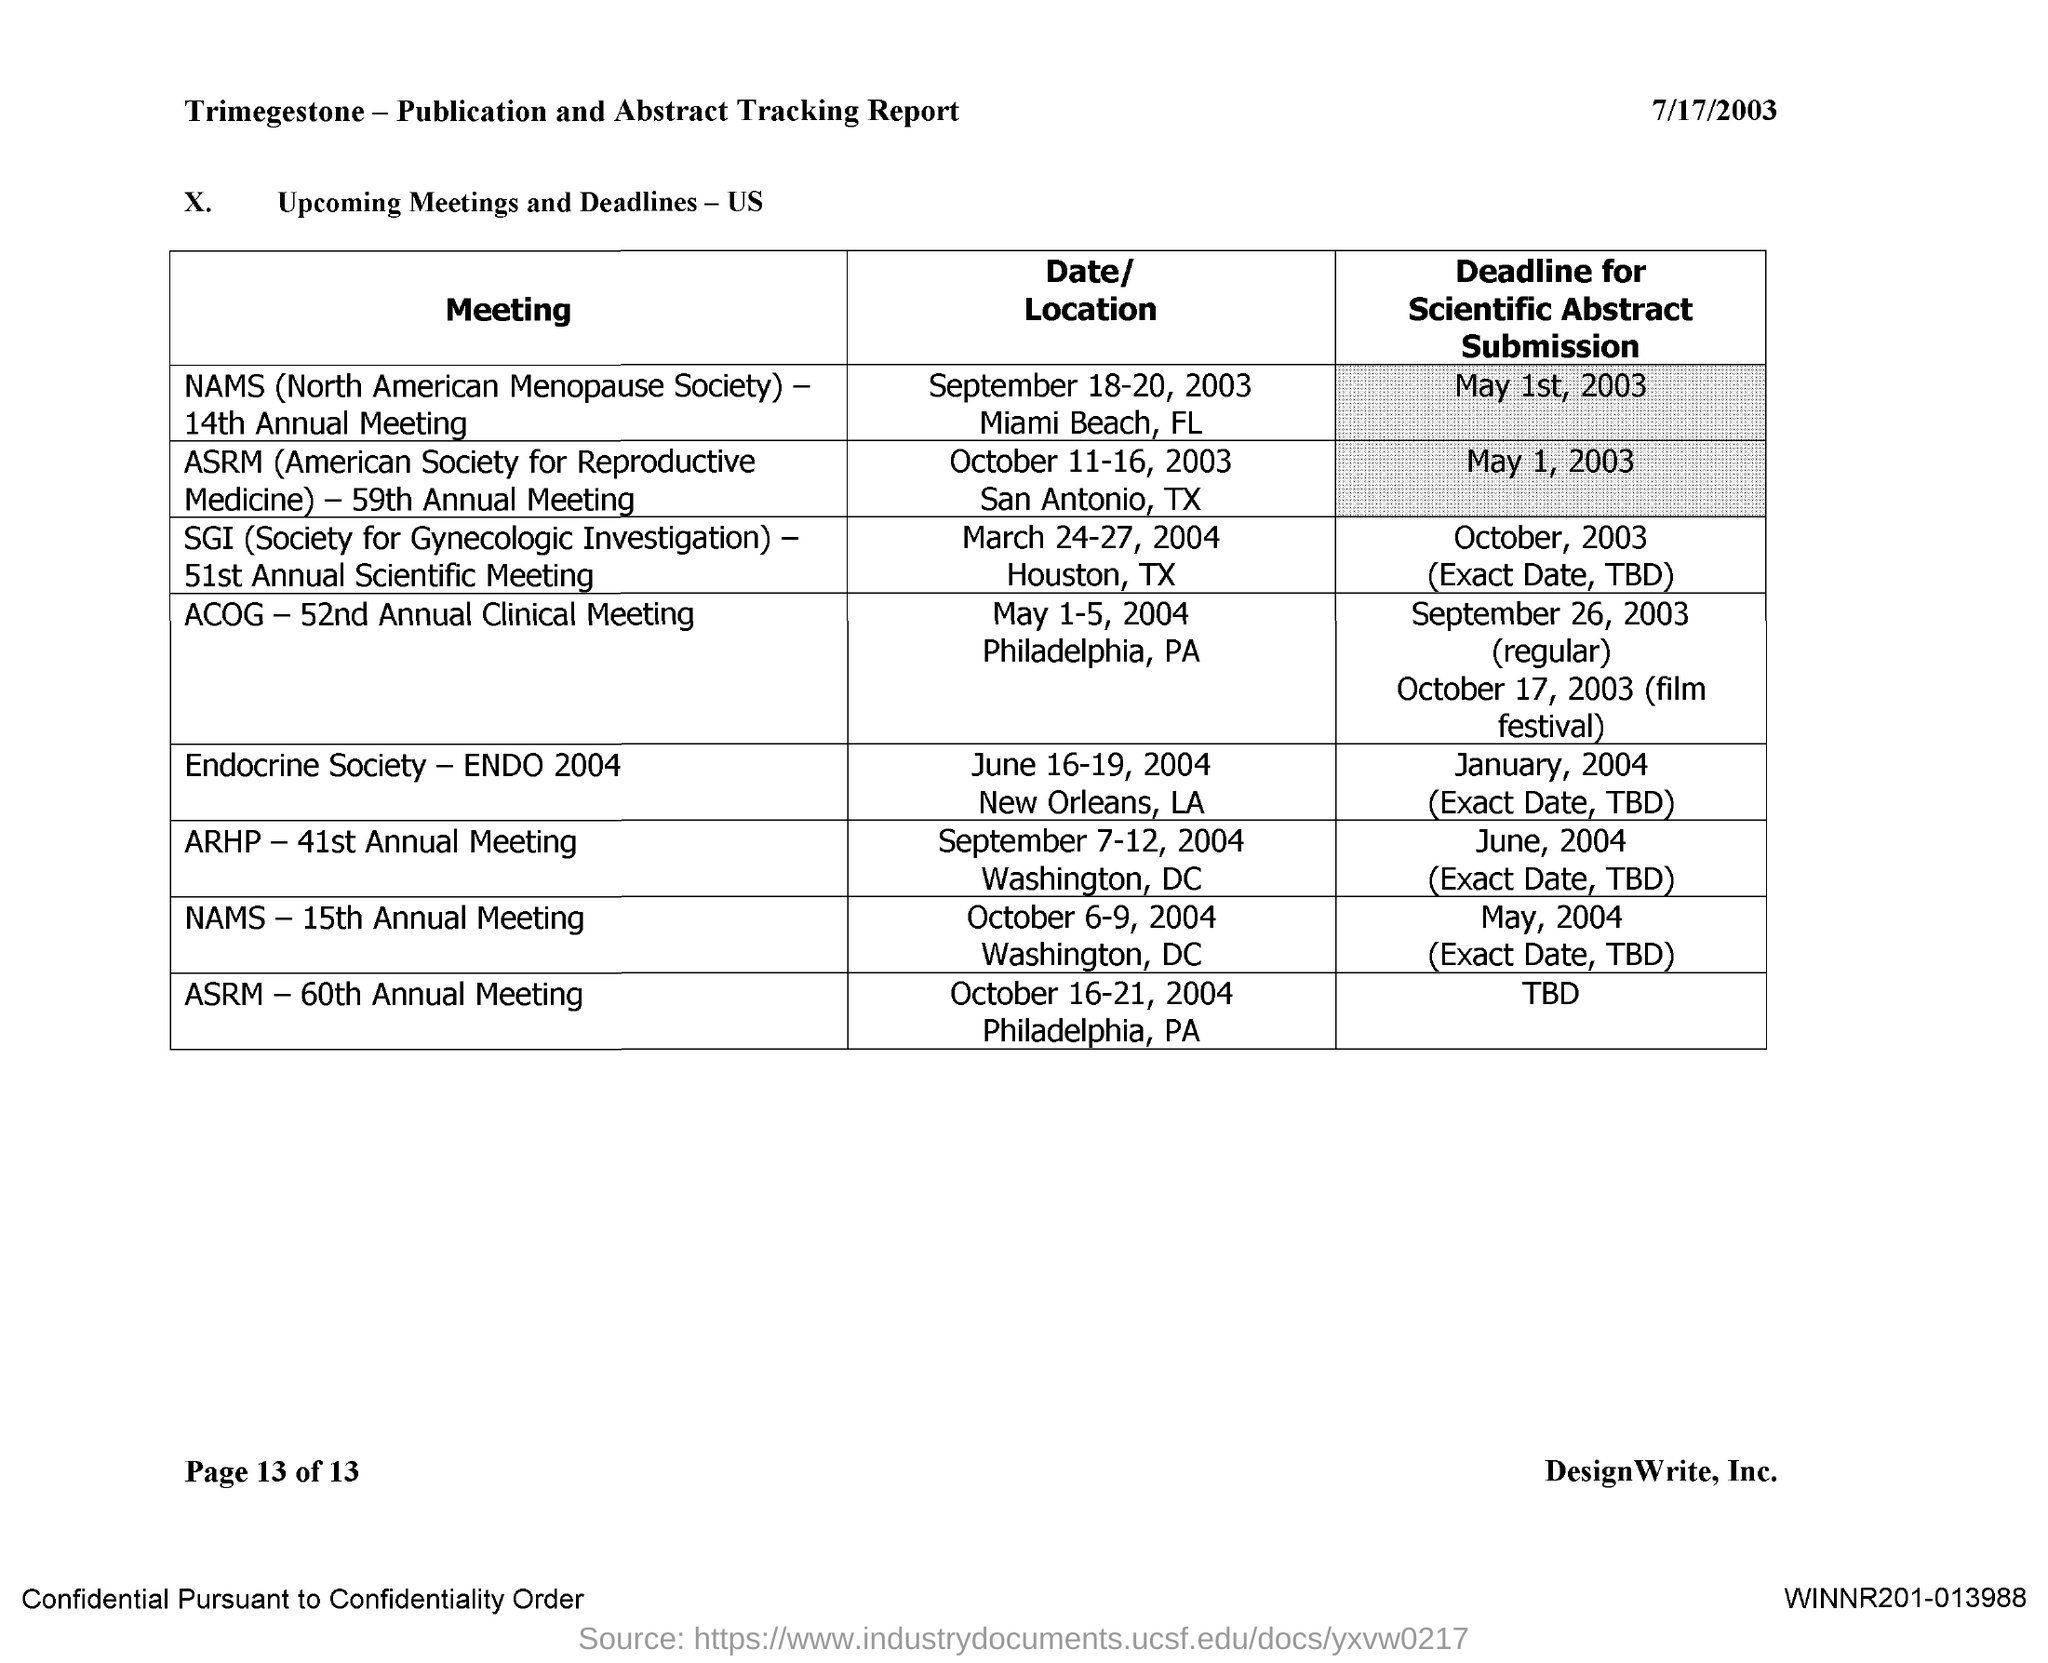What is the Date for ACOG-52nd Annual Clinical Meeting
Keep it short and to the point. May 1-5,2004. 